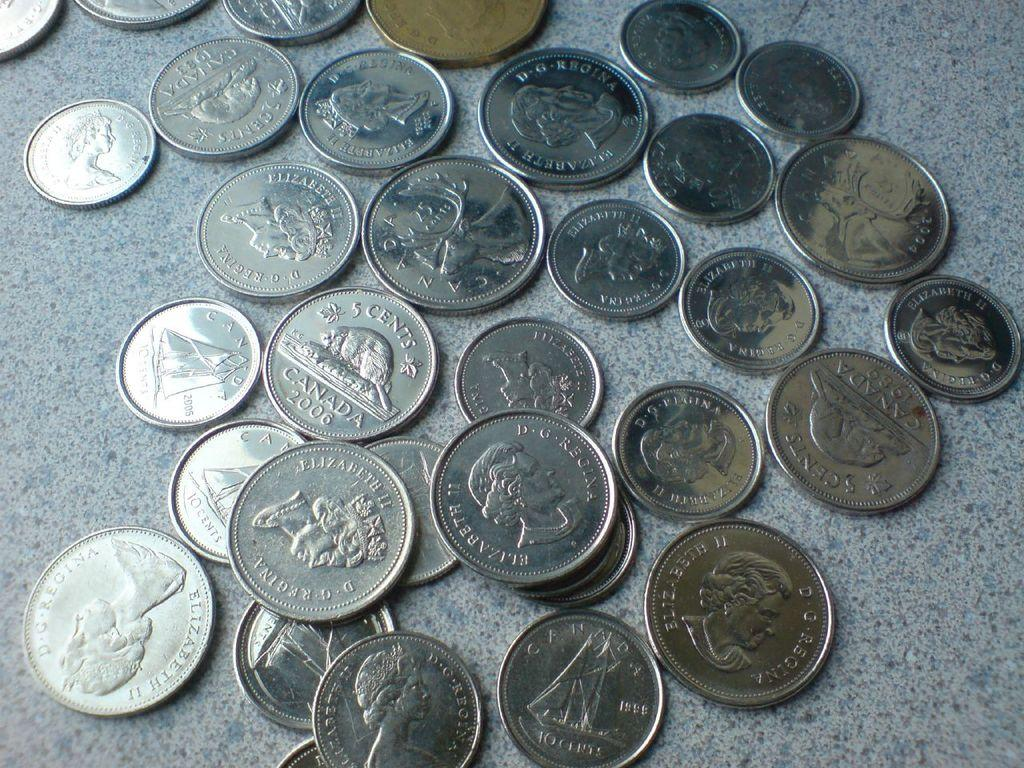What objects are on the floor in the image? There are currency coins on the floor. Are there any other objects or figures accompanying the coins? The image only shows currency coins on the floor. What type of cake is being delivered to the mailbox in the image? There is no cake or mailbox present in the image; it only features currency coins on the floor. 